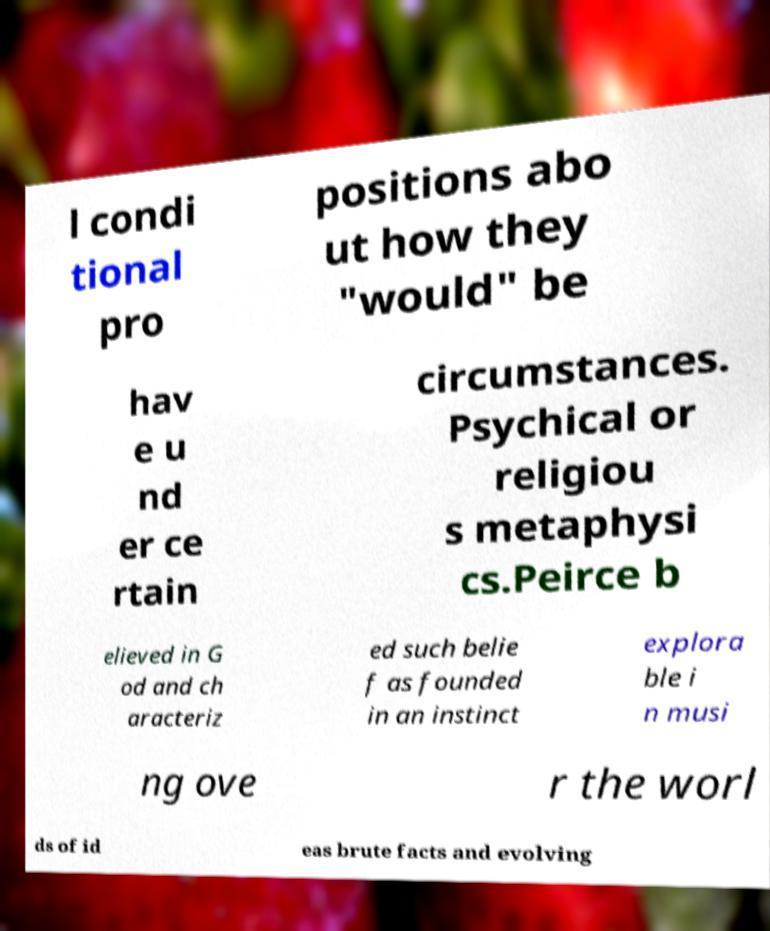Please read and relay the text visible in this image. What does it say? l condi tional pro positions abo ut how they "would" be hav e u nd er ce rtain circumstances. Psychical or religiou s metaphysi cs.Peirce b elieved in G od and ch aracteriz ed such belie f as founded in an instinct explora ble i n musi ng ove r the worl ds of id eas brute facts and evolving 